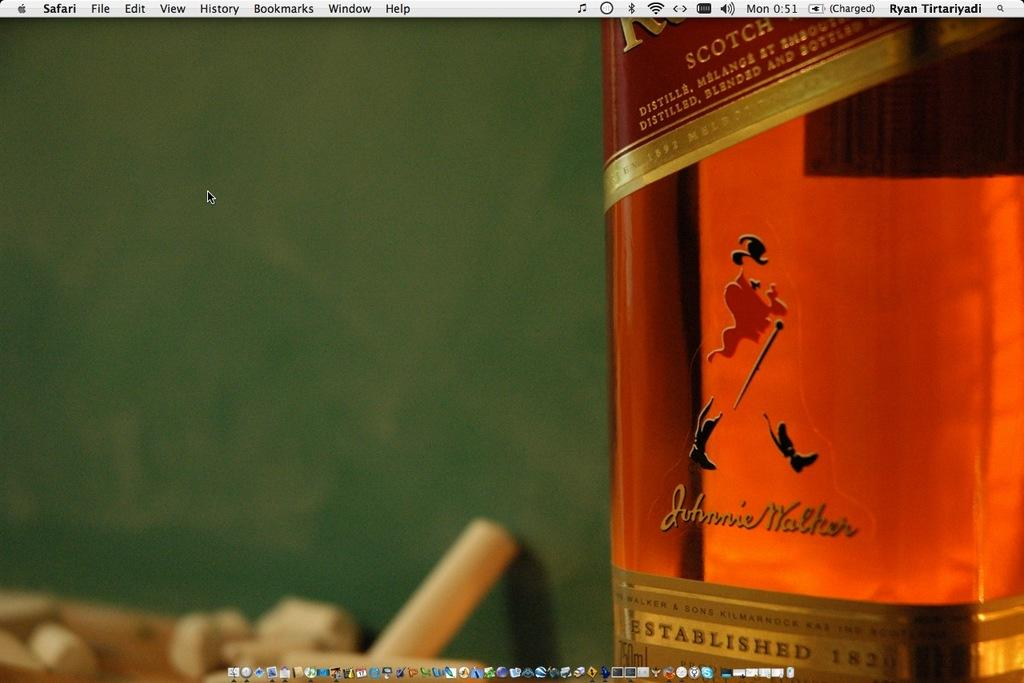What is the main object in the image? There is a wine bottle in the image. What color is the background of the image? The background of the image is green. How much debt is associated with the wine bottle in the image? There is no information about debt in the image, as it only features a wine bottle and a green background. 